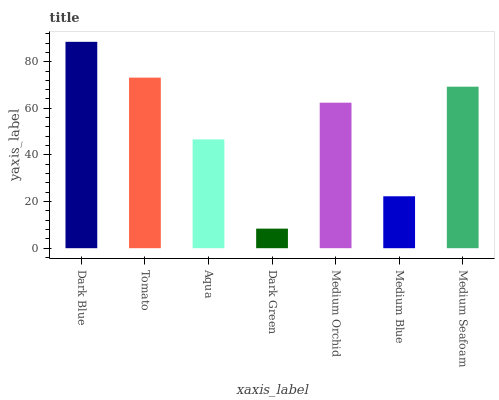Is Dark Green the minimum?
Answer yes or no. Yes. Is Dark Blue the maximum?
Answer yes or no. Yes. Is Tomato the minimum?
Answer yes or no. No. Is Tomato the maximum?
Answer yes or no. No. Is Dark Blue greater than Tomato?
Answer yes or no. Yes. Is Tomato less than Dark Blue?
Answer yes or no. Yes. Is Tomato greater than Dark Blue?
Answer yes or no. No. Is Dark Blue less than Tomato?
Answer yes or no. No. Is Medium Orchid the high median?
Answer yes or no. Yes. Is Medium Orchid the low median?
Answer yes or no. Yes. Is Tomato the high median?
Answer yes or no. No. Is Medium Blue the low median?
Answer yes or no. No. 